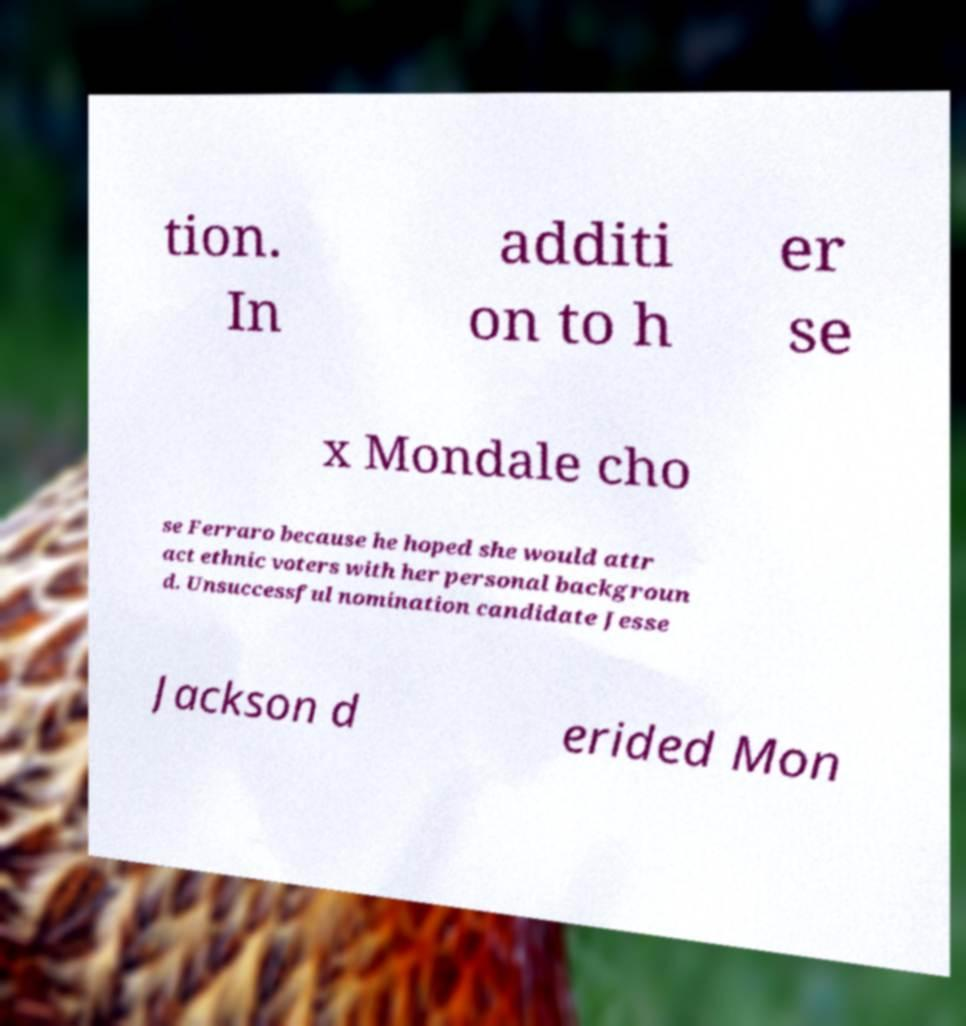Could you assist in decoding the text presented in this image and type it out clearly? tion. In additi on to h er se x Mondale cho se Ferraro because he hoped she would attr act ethnic voters with her personal backgroun d. Unsuccessful nomination candidate Jesse Jackson d erided Mon 